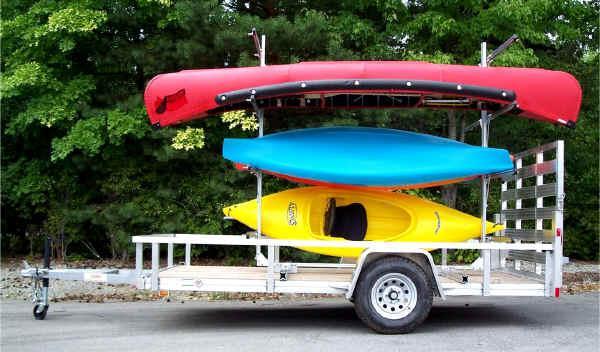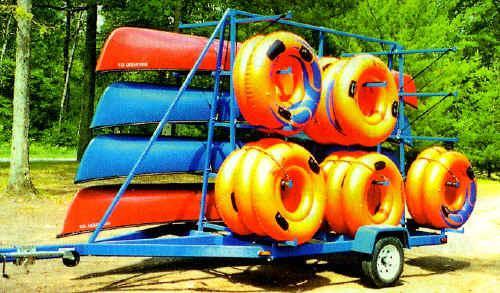The first image is the image on the left, the second image is the image on the right. For the images shown, is this caption "In the image to the left, we have boats of yellow color, red color, and also blue color." true? Answer yes or no. Yes. The first image is the image on the left, the second image is the image on the right. Examine the images to the left and right. Is the description "Each image includes a rack containing at least three boats in bright solid colors." accurate? Answer yes or no. Yes. 